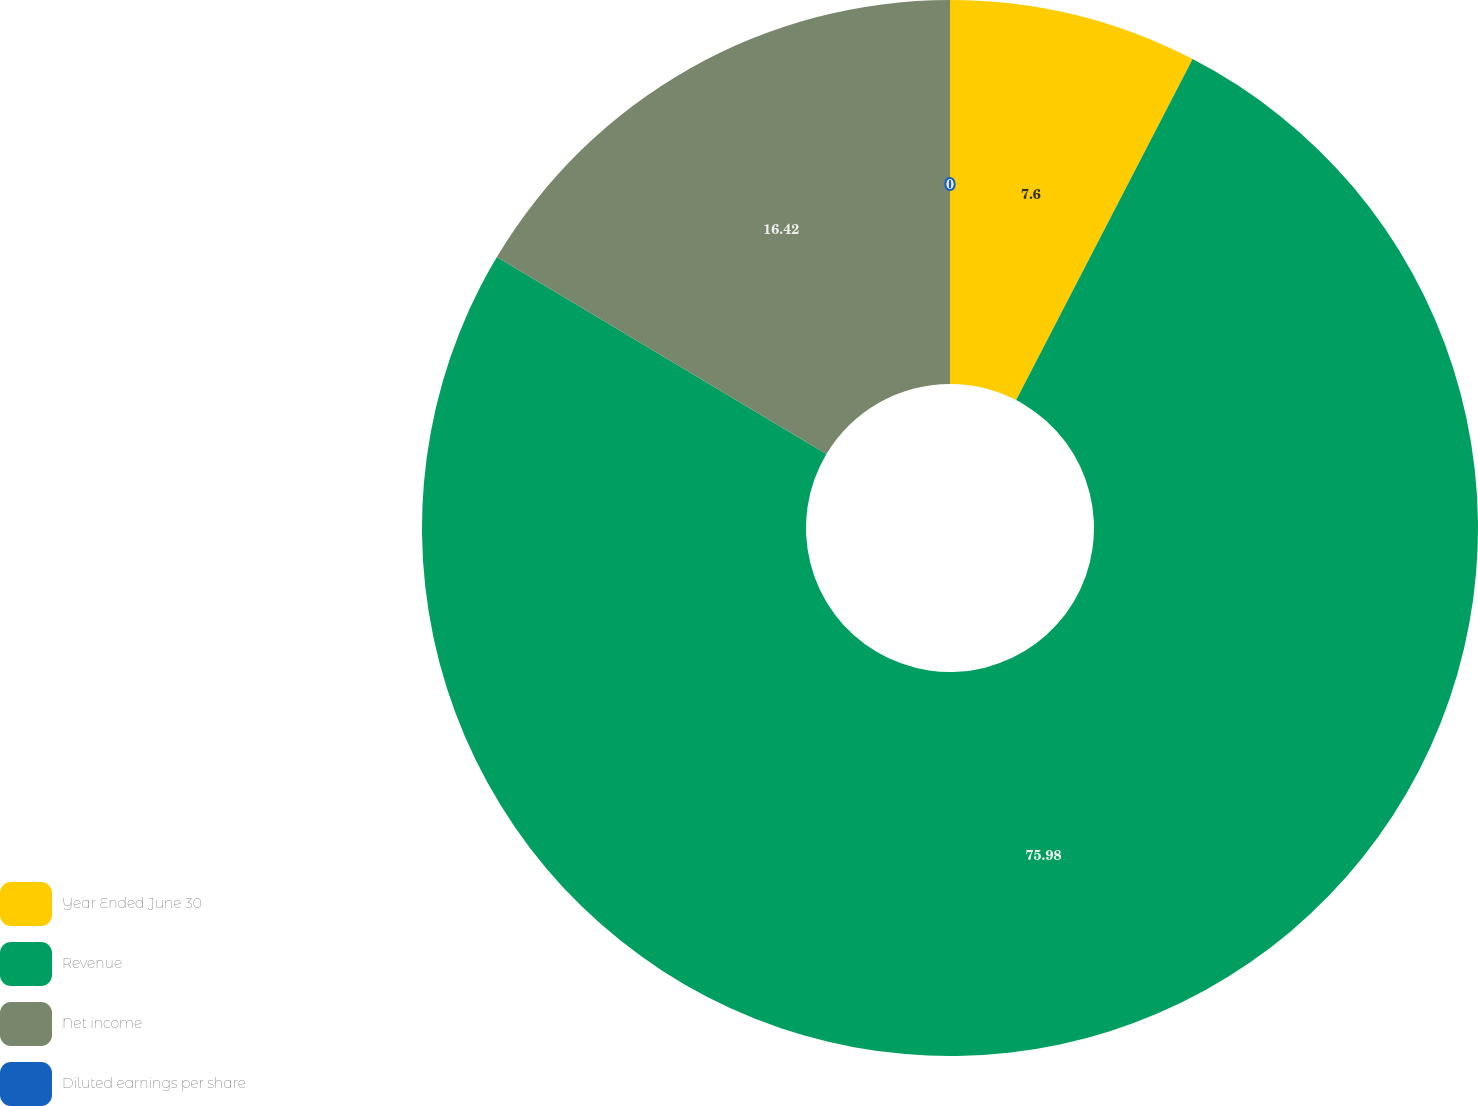Convert chart to OTSL. <chart><loc_0><loc_0><loc_500><loc_500><pie_chart><fcel>Year Ended June 30<fcel>Revenue<fcel>Net income<fcel>Diluted earnings per share<nl><fcel>7.6%<fcel>75.98%<fcel>16.42%<fcel>0.0%<nl></chart> 